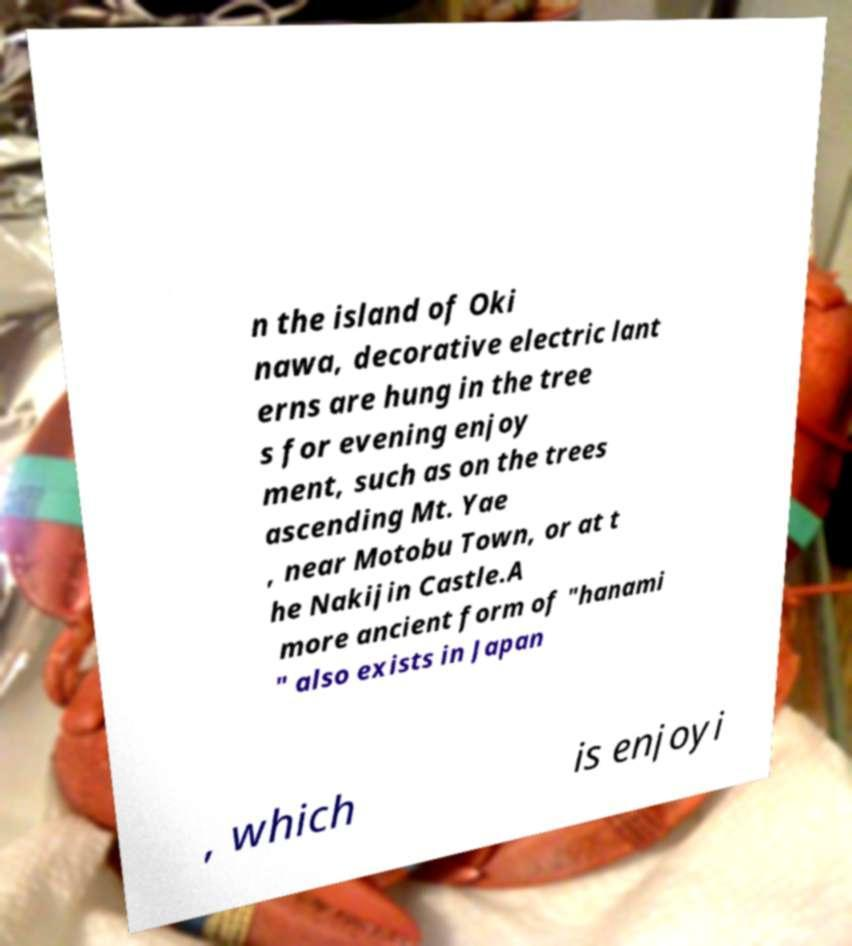What messages or text are displayed in this image? I need them in a readable, typed format. n the island of Oki nawa, decorative electric lant erns are hung in the tree s for evening enjoy ment, such as on the trees ascending Mt. Yae , near Motobu Town, or at t he Nakijin Castle.A more ancient form of "hanami " also exists in Japan , which is enjoyi 